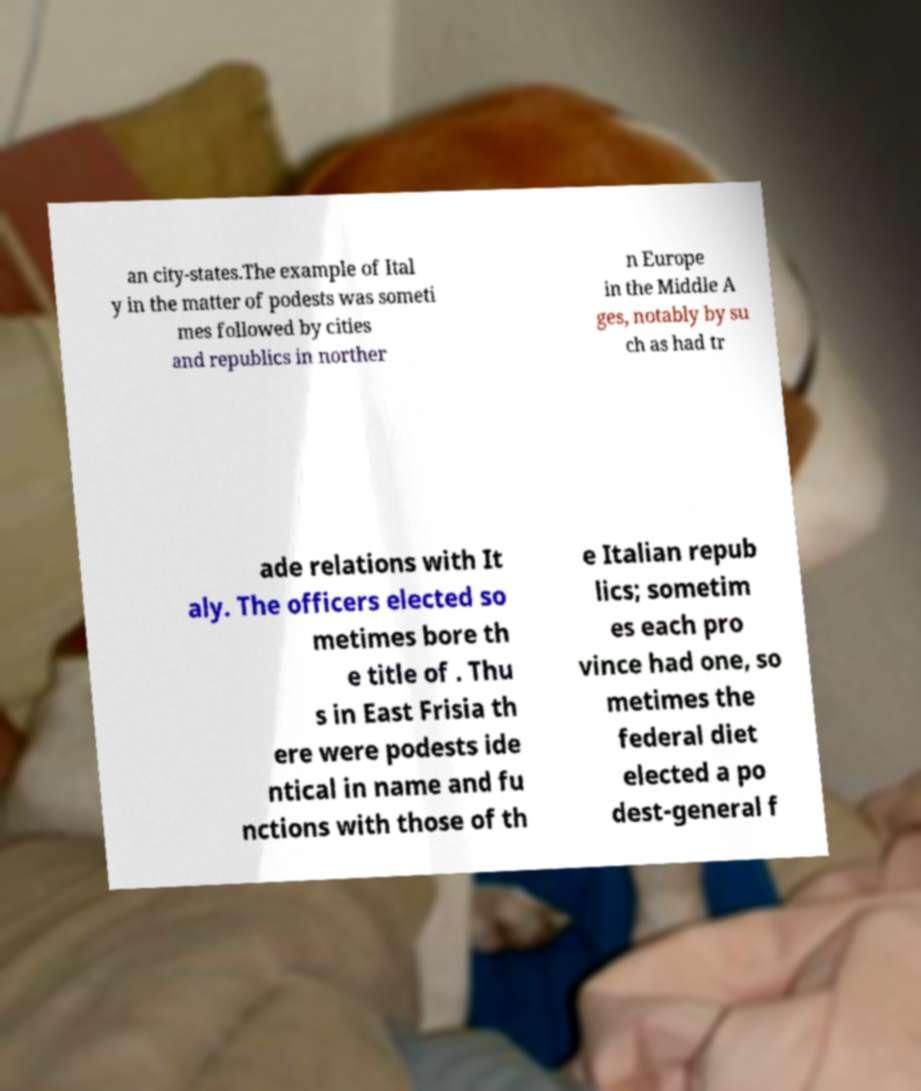For documentation purposes, I need the text within this image transcribed. Could you provide that? an city-states.The example of Ital y in the matter of podests was someti mes followed by cities and republics in norther n Europe in the Middle A ges, notably by su ch as had tr ade relations with It aly. The officers elected so metimes bore th e title of . Thu s in East Frisia th ere were podests ide ntical in name and fu nctions with those of th e Italian repub lics; sometim es each pro vince had one, so metimes the federal diet elected a po dest-general f 